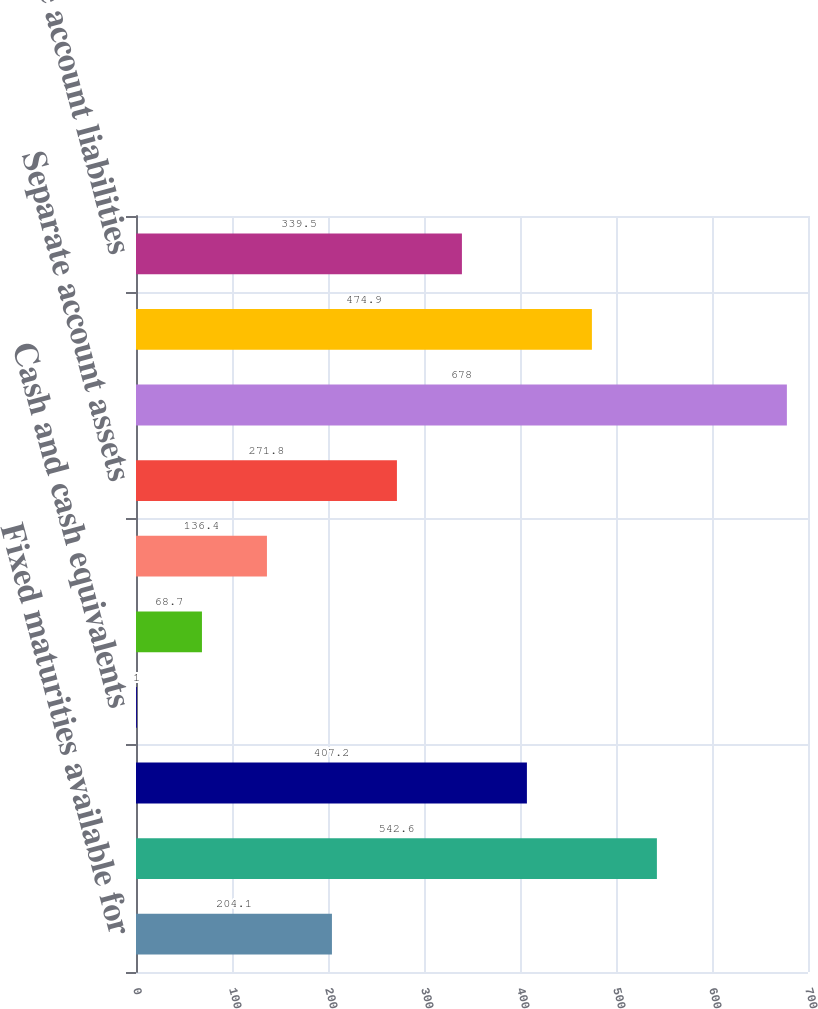Convert chart. <chart><loc_0><loc_0><loc_500><loc_500><bar_chart><fcel>Fixed maturities available for<fcel>Commercial mortgage and other<fcel>Other long-term investments<fcel>Cash and cash equivalents<fcel>Accrued investment income<fcel>Other assets<fcel>Separate account assets<fcel>Total assets of consolidated<fcel>Long-term debt<fcel>Separate account liabilities<nl><fcel>204.1<fcel>542.6<fcel>407.2<fcel>1<fcel>68.7<fcel>136.4<fcel>271.8<fcel>678<fcel>474.9<fcel>339.5<nl></chart> 